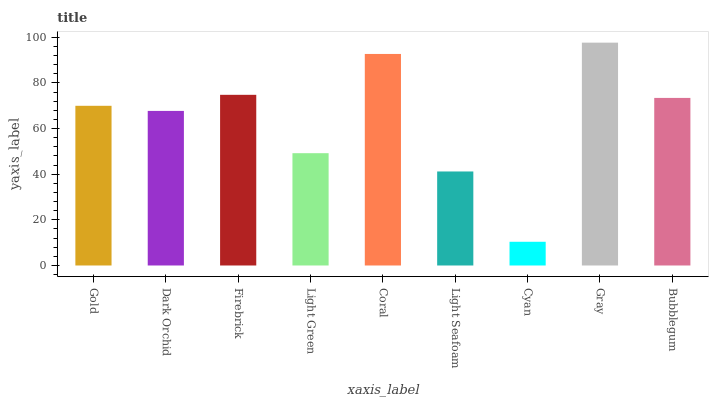Is Cyan the minimum?
Answer yes or no. Yes. Is Gray the maximum?
Answer yes or no. Yes. Is Dark Orchid the minimum?
Answer yes or no. No. Is Dark Orchid the maximum?
Answer yes or no. No. Is Gold greater than Dark Orchid?
Answer yes or no. Yes. Is Dark Orchid less than Gold?
Answer yes or no. Yes. Is Dark Orchid greater than Gold?
Answer yes or no. No. Is Gold less than Dark Orchid?
Answer yes or no. No. Is Gold the high median?
Answer yes or no. Yes. Is Gold the low median?
Answer yes or no. Yes. Is Coral the high median?
Answer yes or no. No. Is Dark Orchid the low median?
Answer yes or no. No. 